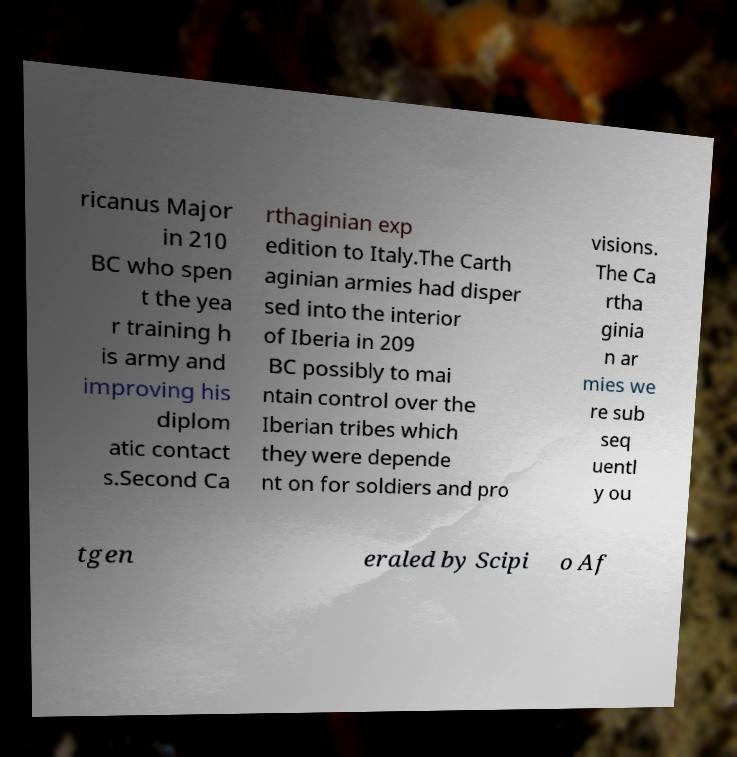I need the written content from this picture converted into text. Can you do that? ricanus Major in 210 BC who spen t the yea r training h is army and improving his diplom atic contact s.Second Ca rthaginian exp edition to Italy.The Carth aginian armies had disper sed into the interior of Iberia in 209 BC possibly to mai ntain control over the Iberian tribes which they were depende nt on for soldiers and pro visions. The Ca rtha ginia n ar mies we re sub seq uentl y ou tgen eraled by Scipi o Af 